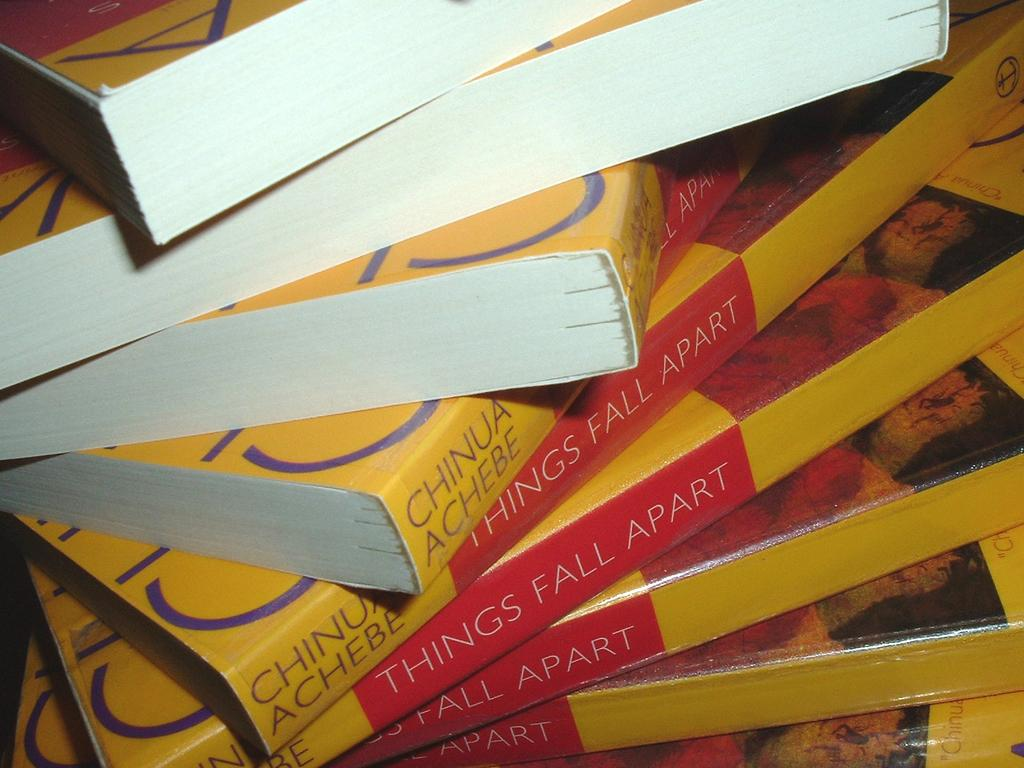<image>
Describe the image concisely. A stack of identical books by author Chinua Achebe is askew. 